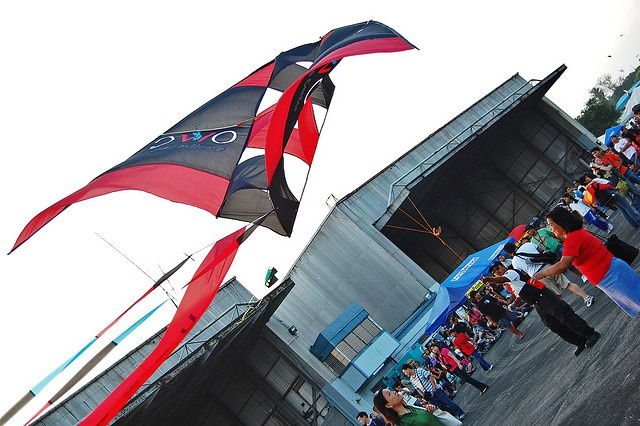Describe the objects in this image and their specific colors. I can see kite in white, gray, salmon, red, and black tones, people in white, black, gray, blue, and navy tones, people in white, brown, blue, and black tones, people in white, black, maroon, and lightblue tones, and people in white, black, gray, and lightblue tones in this image. 